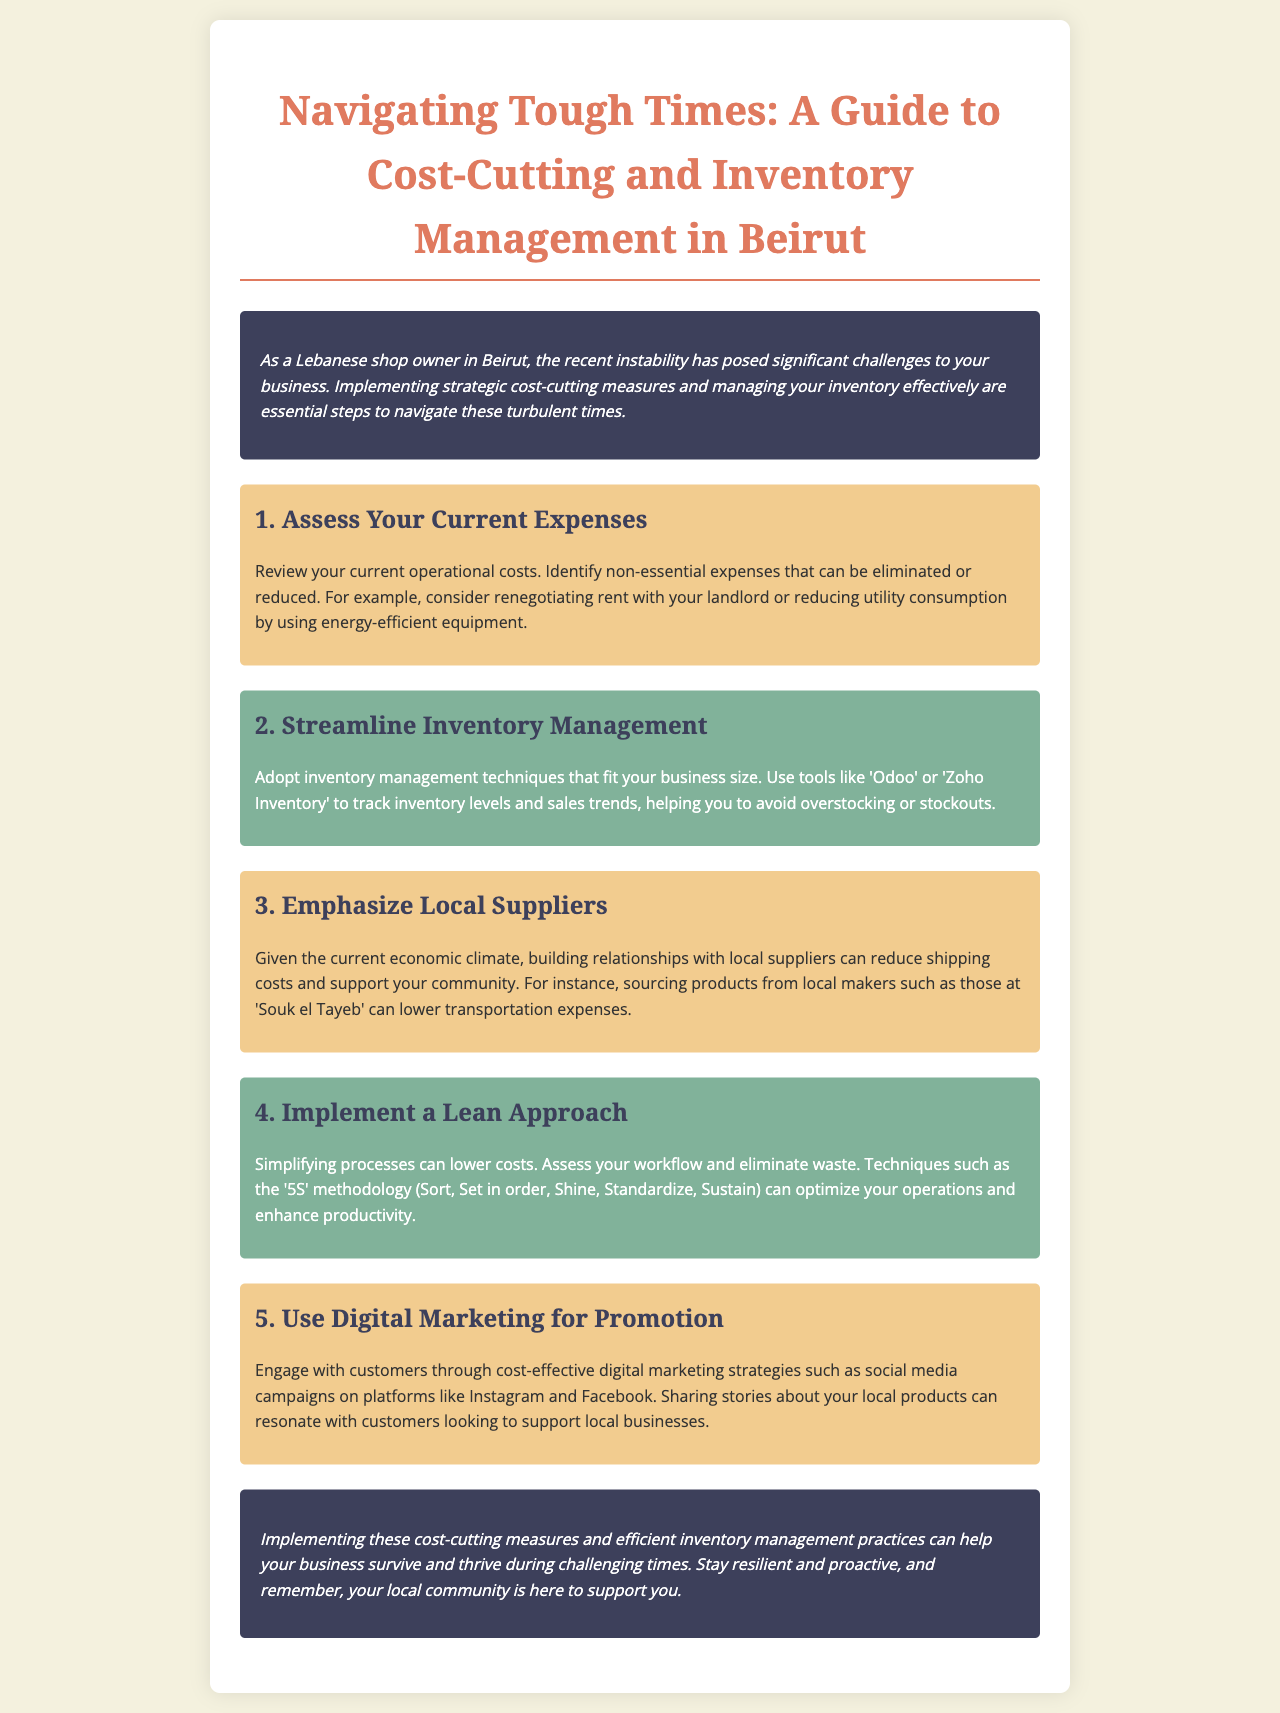what is the title of the document? The title is found at the top of the newsletter and summarizes its content.
Answer: Navigating Tough Times: A Guide to Cost-Cutting and Inventory Management in Beirut what is the first step in cost-cutting measures? The document outlines steps for cost-cutting, with the first one being a specific action.
Answer: Assess Your Current Expenses which inventory management tools are mentioned? The document provides examples of tools relevant for managing inventory effectively.
Answer: Odoo or Zoho Inventory what methodology is suggested for process simplification? The document refers to a technique that helps in optimizing operations.
Answer: 5S how can you promote your business effectively according to the document? The newsletter highlights a method that is cost-effective for engagement with customers.
Answer: Digital Marketing why should one emphasize local suppliers? The document discusses reasons for sourcing locally and its benefits during challenging times.
Answer: Reduce shipping costs and support your community how many sections are there in the newsletter? The number of sections can be counted to understand the structure of the content.
Answer: Five what color is used in the introduction section? The document details the styling of various sections, including this specific one.
Answer: Dark blue what is the final message of the newsletter? The conclusion provides a summary and encouragement for the business owners.
Answer: Stay resilient and proactive 